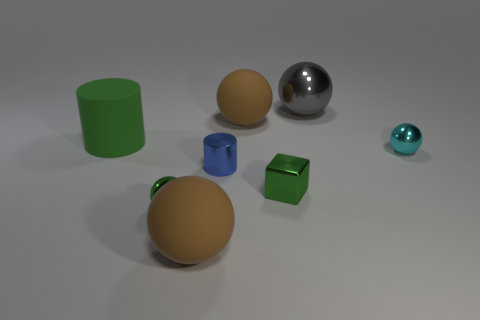Subtract all tiny spheres. How many spheres are left? 3 Subtract 2 balls. How many balls are left? 3 Subtract all brown balls. How many balls are left? 3 Subtract all yellow spheres. Subtract all cyan cylinders. How many spheres are left? 5 Add 1 large yellow matte blocks. How many objects exist? 9 Subtract all blocks. How many objects are left? 7 Add 1 big green cylinders. How many big green cylinders exist? 2 Subtract 0 red cylinders. How many objects are left? 8 Subtract all green shiny cubes. Subtract all gray rubber objects. How many objects are left? 7 Add 7 large gray things. How many large gray things are left? 8 